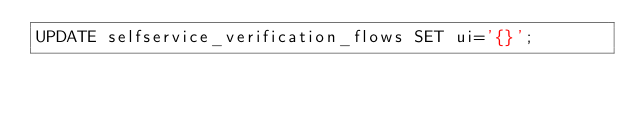<code> <loc_0><loc_0><loc_500><loc_500><_SQL_>UPDATE selfservice_verification_flows SET ui='{}';</code> 